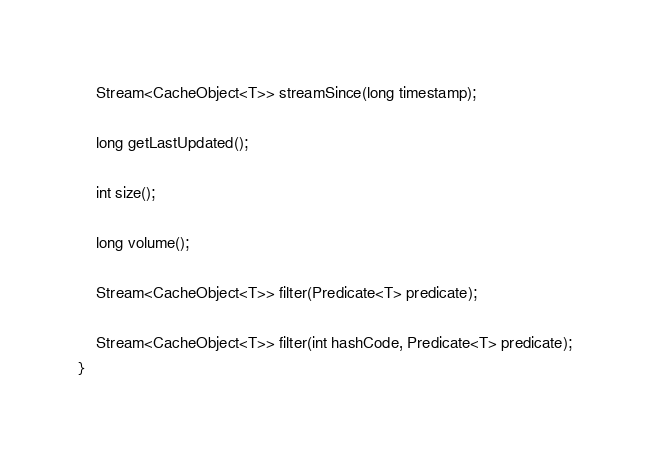<code> <loc_0><loc_0><loc_500><loc_500><_Java_>
    Stream<CacheObject<T>> streamSince(long timestamp);

    long getLastUpdated();

    int size();

    long volume();

    Stream<CacheObject<T>> filter(Predicate<T> predicate);

    Stream<CacheObject<T>> filter(int hashCode, Predicate<T> predicate);
}
</code> 